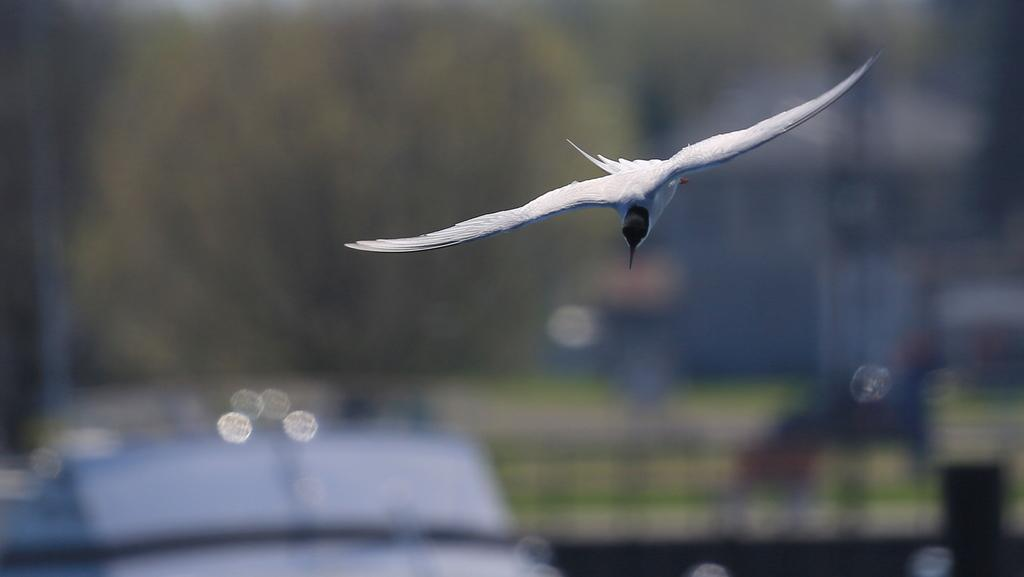What type of animal can be seen in the image? There is a white bird in the image. What is the bird doing in the image? The bird is flying in the air. What else can be seen in the background of the image? There is a vehicle in the background of the image. How many cherries can be seen on the bird's back in the image? There are no cherries present in the image, and the bird's back is not visible. Is there a bear swimming in the sea in the image? There is no bear or sea present in the image; it features a white bird flying in the air. 